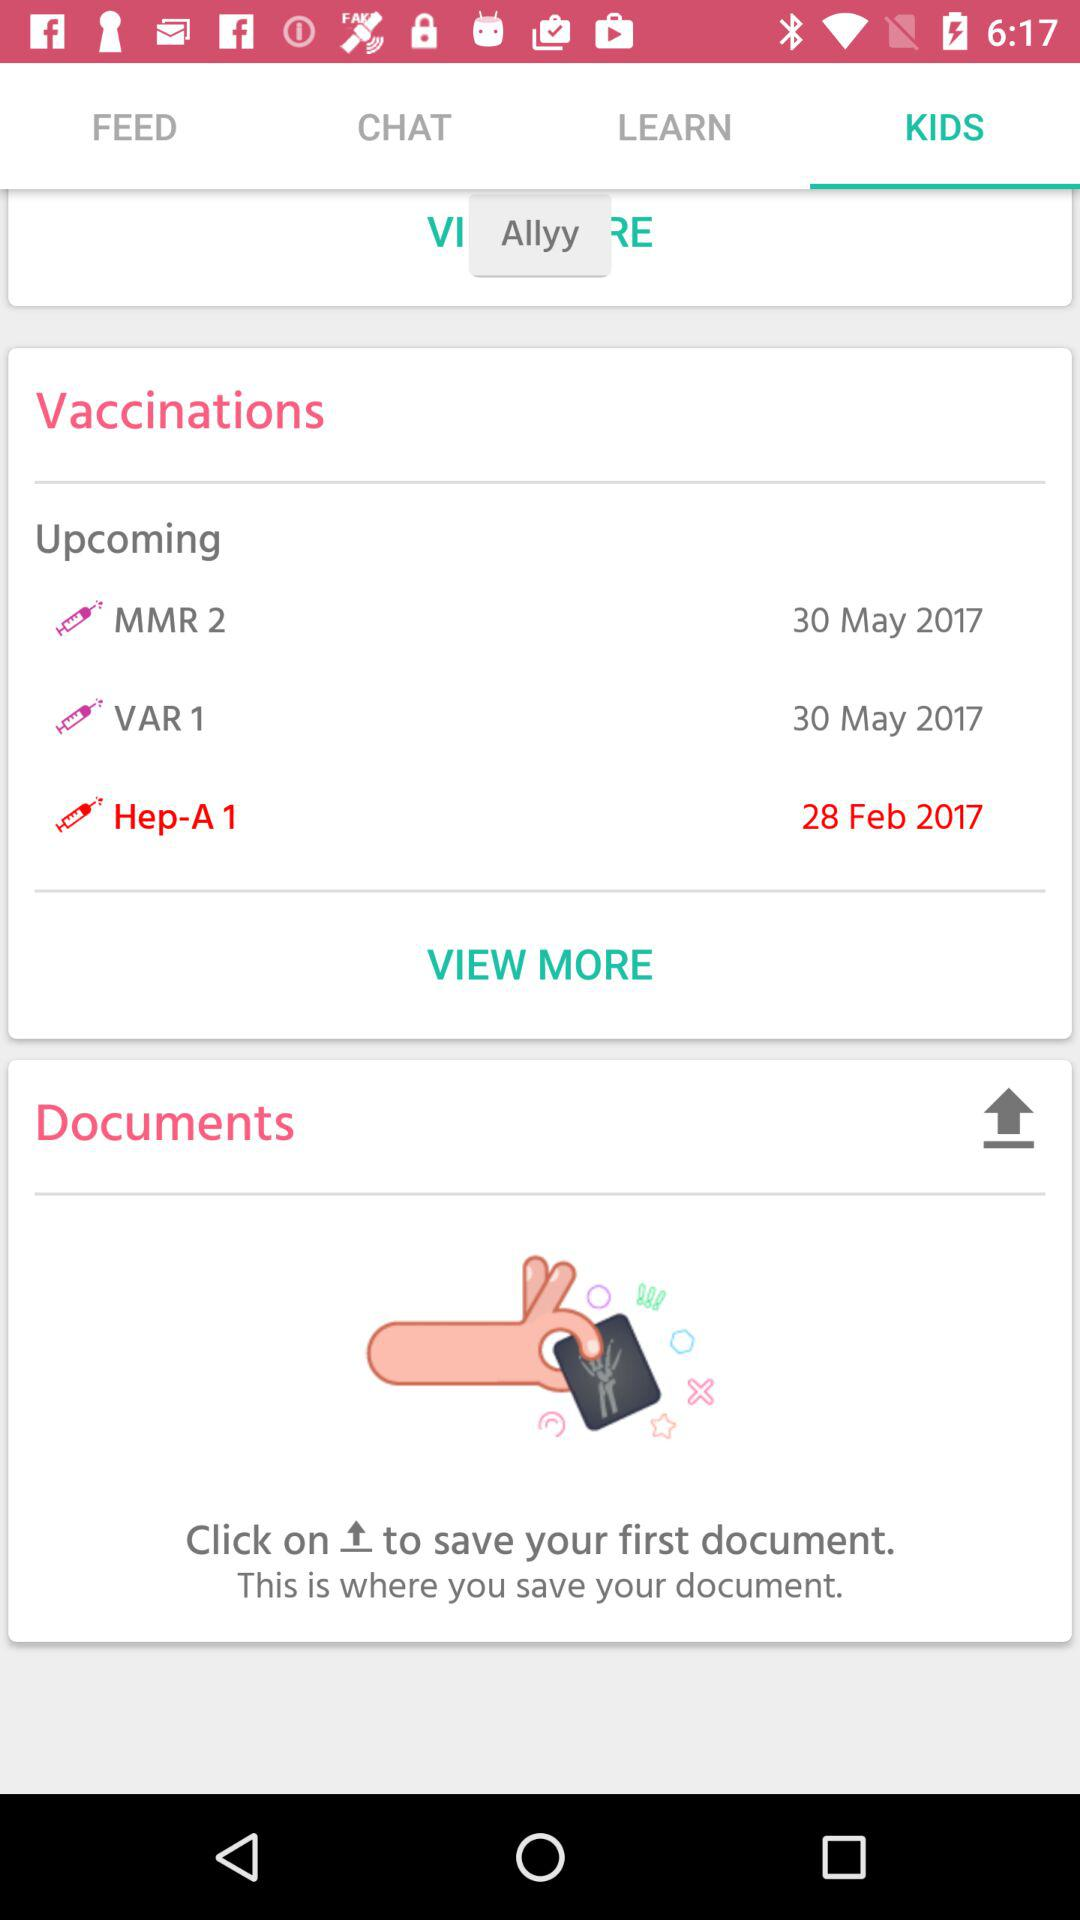How many vaccinations are scheduled for the month of May?
Answer the question using a single word or phrase. 2 